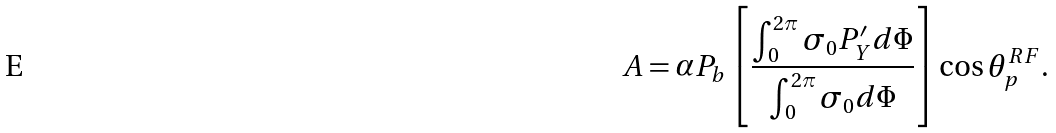Convert formula to latex. <formula><loc_0><loc_0><loc_500><loc_500>A = \alpha P _ { b } \left [ \frac { \int _ { 0 } ^ { 2 \pi } \sigma _ { 0 } P _ { Y } ^ { \prime } d \Phi } { \int _ { 0 } ^ { 2 \pi } \sigma _ { 0 } d \Phi } \right ] \cos \theta _ { p } ^ { R F } .</formula> 